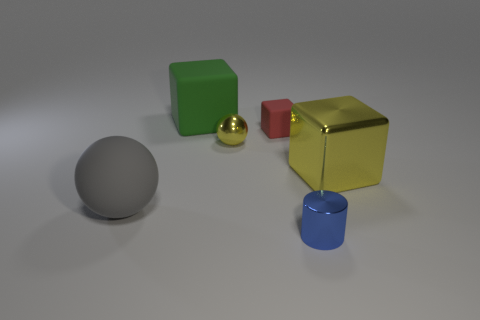Add 4 blue metal cylinders. How many objects exist? 10 Subtract all balls. How many objects are left? 4 Add 5 yellow shiny spheres. How many yellow shiny spheres exist? 6 Subtract 0 yellow cylinders. How many objects are left? 6 Subtract all green rubber blocks. Subtract all small blocks. How many objects are left? 4 Add 3 large gray spheres. How many large gray spheres are left? 4 